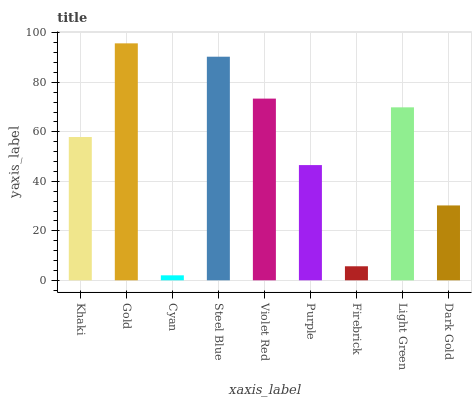Is Gold the minimum?
Answer yes or no. No. Is Cyan the maximum?
Answer yes or no. No. Is Gold greater than Cyan?
Answer yes or no. Yes. Is Cyan less than Gold?
Answer yes or no. Yes. Is Cyan greater than Gold?
Answer yes or no. No. Is Gold less than Cyan?
Answer yes or no. No. Is Khaki the high median?
Answer yes or no. Yes. Is Khaki the low median?
Answer yes or no. Yes. Is Cyan the high median?
Answer yes or no. No. Is Purple the low median?
Answer yes or no. No. 